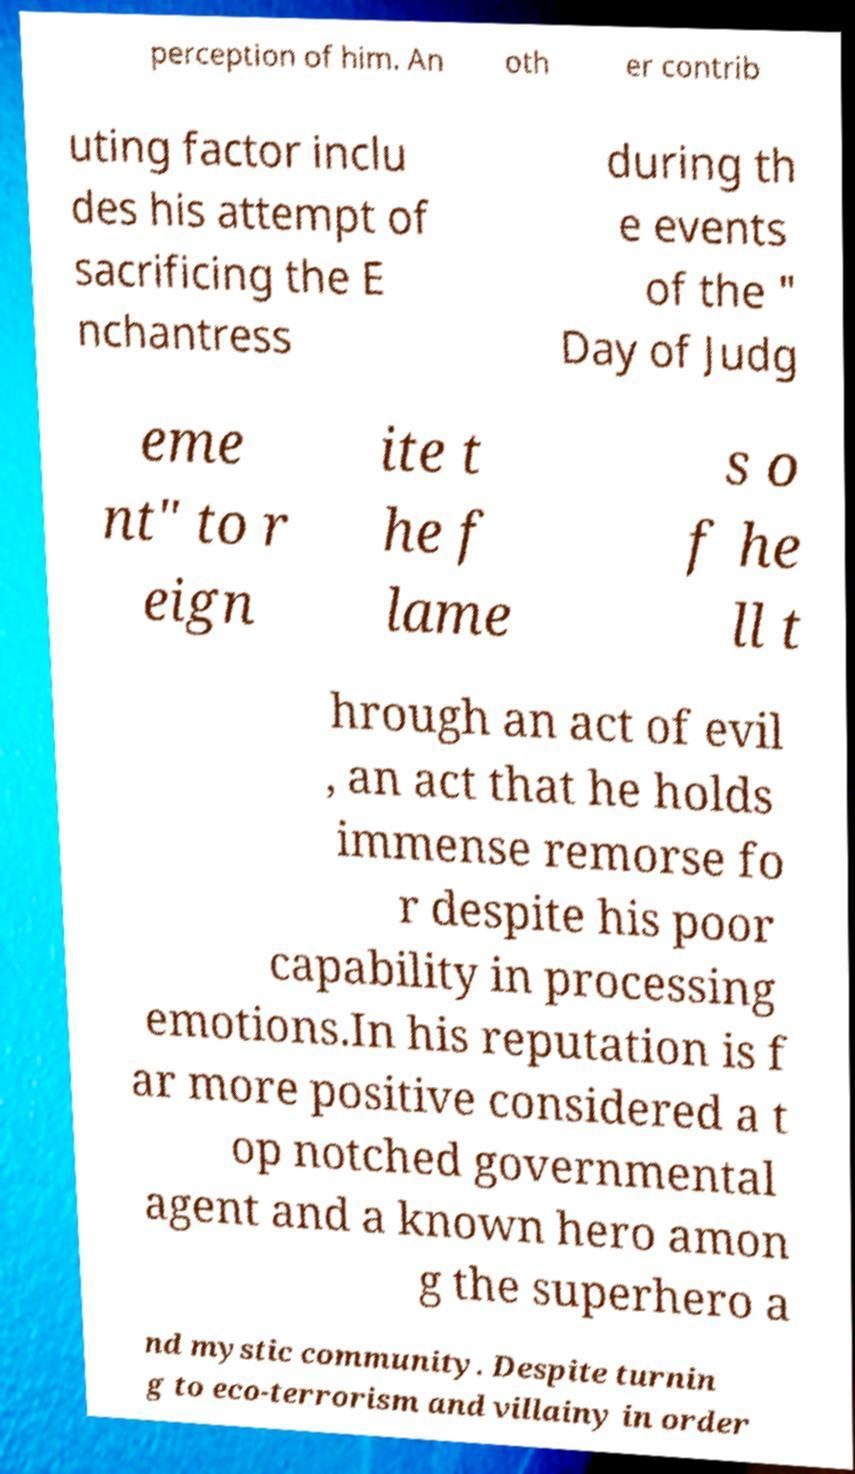Can you accurately transcribe the text from the provided image for me? perception of him. An oth er contrib uting factor inclu des his attempt of sacrificing the E nchantress during th e events of the " Day of Judg eme nt" to r eign ite t he f lame s o f he ll t hrough an act of evil , an act that he holds immense remorse fo r despite his poor capability in processing emotions.In his reputation is f ar more positive considered a t op notched governmental agent and a known hero amon g the superhero a nd mystic community. Despite turnin g to eco-terrorism and villainy in order 